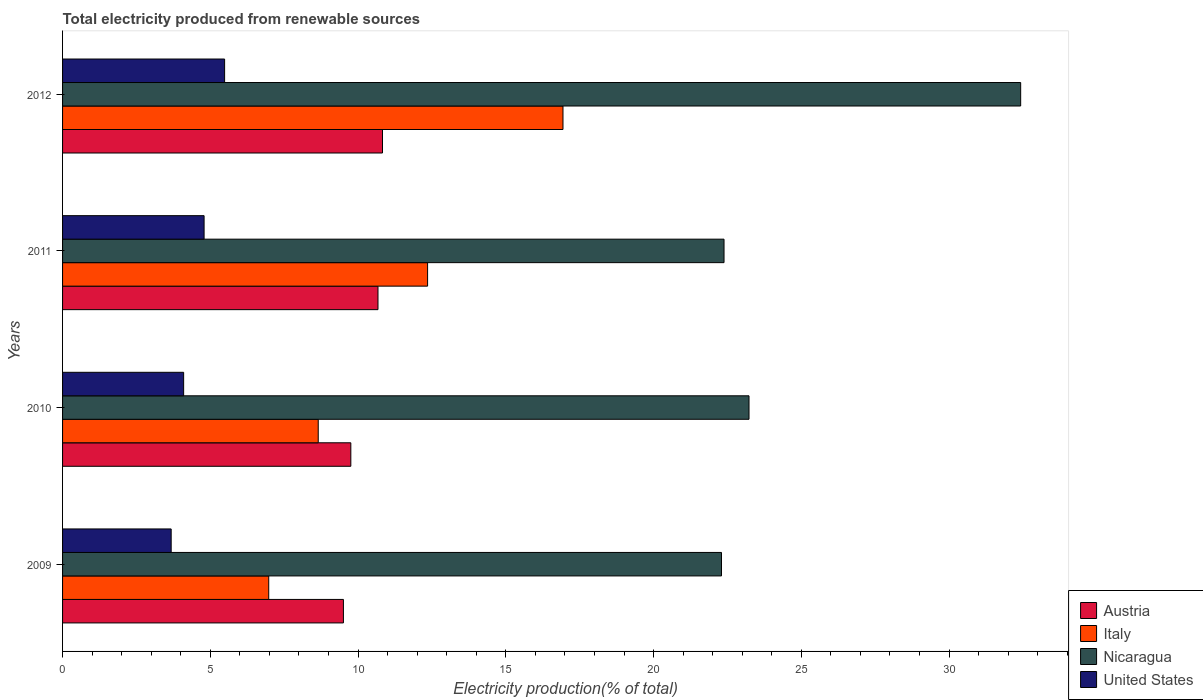How many groups of bars are there?
Your answer should be compact. 4. Are the number of bars on each tick of the Y-axis equal?
Your answer should be compact. Yes. How many bars are there on the 2nd tick from the top?
Ensure brevity in your answer.  4. What is the label of the 3rd group of bars from the top?
Ensure brevity in your answer.  2010. In how many cases, is the number of bars for a given year not equal to the number of legend labels?
Your answer should be compact. 0. What is the total electricity produced in Austria in 2012?
Make the answer very short. 10.83. Across all years, what is the maximum total electricity produced in United States?
Offer a very short reply. 5.48. Across all years, what is the minimum total electricity produced in United States?
Offer a terse response. 3.68. In which year was the total electricity produced in Italy maximum?
Give a very brief answer. 2012. In which year was the total electricity produced in Nicaragua minimum?
Provide a short and direct response. 2009. What is the total total electricity produced in Austria in the graph?
Keep it short and to the point. 40.76. What is the difference between the total electricity produced in Austria in 2010 and that in 2011?
Give a very brief answer. -0.92. What is the difference between the total electricity produced in United States in 2010 and the total electricity produced in Nicaragua in 2009?
Offer a terse response. -18.2. What is the average total electricity produced in Austria per year?
Offer a very short reply. 10.19. In the year 2010, what is the difference between the total electricity produced in Nicaragua and total electricity produced in Austria?
Ensure brevity in your answer.  13.48. In how many years, is the total electricity produced in United States greater than 30 %?
Provide a succinct answer. 0. What is the ratio of the total electricity produced in Austria in 2009 to that in 2010?
Ensure brevity in your answer.  0.97. What is the difference between the highest and the second highest total electricity produced in United States?
Your response must be concise. 0.69. What is the difference between the highest and the lowest total electricity produced in Italy?
Give a very brief answer. 9.96. Is the sum of the total electricity produced in Italy in 2010 and 2011 greater than the maximum total electricity produced in Austria across all years?
Ensure brevity in your answer.  Yes. What does the 2nd bar from the top in 2011 represents?
Your answer should be compact. Nicaragua. What does the 1st bar from the bottom in 2010 represents?
Your response must be concise. Austria. How many bars are there?
Offer a terse response. 16. How many years are there in the graph?
Your answer should be very brief. 4. Does the graph contain grids?
Your answer should be very brief. No. Where does the legend appear in the graph?
Ensure brevity in your answer.  Bottom right. How many legend labels are there?
Provide a succinct answer. 4. How are the legend labels stacked?
Provide a short and direct response. Vertical. What is the title of the graph?
Make the answer very short. Total electricity produced from renewable sources. Does "Norway" appear as one of the legend labels in the graph?
Your response must be concise. No. What is the Electricity production(% of total) in Austria in 2009?
Your response must be concise. 9.5. What is the Electricity production(% of total) in Italy in 2009?
Ensure brevity in your answer.  6.98. What is the Electricity production(% of total) of Nicaragua in 2009?
Your answer should be very brief. 22.3. What is the Electricity production(% of total) of United States in 2009?
Your answer should be very brief. 3.68. What is the Electricity production(% of total) of Austria in 2010?
Provide a short and direct response. 9.76. What is the Electricity production(% of total) of Italy in 2010?
Keep it short and to the point. 8.65. What is the Electricity production(% of total) of Nicaragua in 2010?
Your answer should be very brief. 23.23. What is the Electricity production(% of total) in United States in 2010?
Provide a short and direct response. 4.1. What is the Electricity production(% of total) in Austria in 2011?
Your response must be concise. 10.67. What is the Electricity production(% of total) in Italy in 2011?
Ensure brevity in your answer.  12.35. What is the Electricity production(% of total) in Nicaragua in 2011?
Your answer should be very brief. 22.38. What is the Electricity production(% of total) in United States in 2011?
Give a very brief answer. 4.79. What is the Electricity production(% of total) of Austria in 2012?
Make the answer very short. 10.83. What is the Electricity production(% of total) in Italy in 2012?
Your answer should be compact. 16.94. What is the Electricity production(% of total) of Nicaragua in 2012?
Offer a terse response. 32.42. What is the Electricity production(% of total) in United States in 2012?
Your response must be concise. 5.48. Across all years, what is the maximum Electricity production(% of total) in Austria?
Offer a terse response. 10.83. Across all years, what is the maximum Electricity production(% of total) of Italy?
Keep it short and to the point. 16.94. Across all years, what is the maximum Electricity production(% of total) of Nicaragua?
Offer a very short reply. 32.42. Across all years, what is the maximum Electricity production(% of total) in United States?
Provide a short and direct response. 5.48. Across all years, what is the minimum Electricity production(% of total) of Austria?
Your answer should be very brief. 9.5. Across all years, what is the minimum Electricity production(% of total) in Italy?
Provide a succinct answer. 6.98. Across all years, what is the minimum Electricity production(% of total) of Nicaragua?
Offer a very short reply. 22.3. Across all years, what is the minimum Electricity production(% of total) in United States?
Provide a succinct answer. 3.68. What is the total Electricity production(% of total) of Austria in the graph?
Your answer should be compact. 40.76. What is the total Electricity production(% of total) of Italy in the graph?
Your response must be concise. 44.92. What is the total Electricity production(% of total) of Nicaragua in the graph?
Provide a succinct answer. 100.34. What is the total Electricity production(% of total) in United States in the graph?
Ensure brevity in your answer.  18.05. What is the difference between the Electricity production(% of total) of Austria in 2009 and that in 2010?
Your response must be concise. -0.25. What is the difference between the Electricity production(% of total) in Italy in 2009 and that in 2010?
Your response must be concise. -1.67. What is the difference between the Electricity production(% of total) in Nicaragua in 2009 and that in 2010?
Offer a very short reply. -0.93. What is the difference between the Electricity production(% of total) in United States in 2009 and that in 2010?
Your answer should be very brief. -0.42. What is the difference between the Electricity production(% of total) of Austria in 2009 and that in 2011?
Your response must be concise. -1.17. What is the difference between the Electricity production(% of total) in Italy in 2009 and that in 2011?
Give a very brief answer. -5.38. What is the difference between the Electricity production(% of total) of Nicaragua in 2009 and that in 2011?
Your answer should be very brief. -0.09. What is the difference between the Electricity production(% of total) of United States in 2009 and that in 2011?
Offer a very short reply. -1.11. What is the difference between the Electricity production(% of total) in Austria in 2009 and that in 2012?
Give a very brief answer. -1.32. What is the difference between the Electricity production(% of total) of Italy in 2009 and that in 2012?
Give a very brief answer. -9.96. What is the difference between the Electricity production(% of total) of Nicaragua in 2009 and that in 2012?
Provide a succinct answer. -10.12. What is the difference between the Electricity production(% of total) of United States in 2009 and that in 2012?
Provide a succinct answer. -1.81. What is the difference between the Electricity production(% of total) of Austria in 2010 and that in 2011?
Your answer should be very brief. -0.92. What is the difference between the Electricity production(% of total) of Italy in 2010 and that in 2011?
Give a very brief answer. -3.7. What is the difference between the Electricity production(% of total) in Nicaragua in 2010 and that in 2011?
Your answer should be very brief. 0.85. What is the difference between the Electricity production(% of total) of United States in 2010 and that in 2011?
Keep it short and to the point. -0.69. What is the difference between the Electricity production(% of total) in Austria in 2010 and that in 2012?
Ensure brevity in your answer.  -1.07. What is the difference between the Electricity production(% of total) in Italy in 2010 and that in 2012?
Provide a succinct answer. -8.28. What is the difference between the Electricity production(% of total) in Nicaragua in 2010 and that in 2012?
Make the answer very short. -9.19. What is the difference between the Electricity production(% of total) in United States in 2010 and that in 2012?
Ensure brevity in your answer.  -1.39. What is the difference between the Electricity production(% of total) of Austria in 2011 and that in 2012?
Offer a very short reply. -0.15. What is the difference between the Electricity production(% of total) of Italy in 2011 and that in 2012?
Provide a succinct answer. -4.58. What is the difference between the Electricity production(% of total) in Nicaragua in 2011 and that in 2012?
Provide a succinct answer. -10.04. What is the difference between the Electricity production(% of total) in United States in 2011 and that in 2012?
Offer a terse response. -0.69. What is the difference between the Electricity production(% of total) of Austria in 2009 and the Electricity production(% of total) of Italy in 2010?
Make the answer very short. 0.85. What is the difference between the Electricity production(% of total) in Austria in 2009 and the Electricity production(% of total) in Nicaragua in 2010?
Your answer should be very brief. -13.73. What is the difference between the Electricity production(% of total) in Austria in 2009 and the Electricity production(% of total) in United States in 2010?
Your response must be concise. 5.41. What is the difference between the Electricity production(% of total) of Italy in 2009 and the Electricity production(% of total) of Nicaragua in 2010?
Your answer should be compact. -16.25. What is the difference between the Electricity production(% of total) of Italy in 2009 and the Electricity production(% of total) of United States in 2010?
Your answer should be compact. 2.88. What is the difference between the Electricity production(% of total) of Nicaragua in 2009 and the Electricity production(% of total) of United States in 2010?
Offer a terse response. 18.2. What is the difference between the Electricity production(% of total) in Austria in 2009 and the Electricity production(% of total) in Italy in 2011?
Your answer should be very brief. -2.85. What is the difference between the Electricity production(% of total) of Austria in 2009 and the Electricity production(% of total) of Nicaragua in 2011?
Provide a short and direct response. -12.88. What is the difference between the Electricity production(% of total) in Austria in 2009 and the Electricity production(% of total) in United States in 2011?
Your answer should be very brief. 4.72. What is the difference between the Electricity production(% of total) of Italy in 2009 and the Electricity production(% of total) of Nicaragua in 2011?
Make the answer very short. -15.41. What is the difference between the Electricity production(% of total) of Italy in 2009 and the Electricity production(% of total) of United States in 2011?
Your answer should be very brief. 2.19. What is the difference between the Electricity production(% of total) of Nicaragua in 2009 and the Electricity production(% of total) of United States in 2011?
Provide a short and direct response. 17.51. What is the difference between the Electricity production(% of total) of Austria in 2009 and the Electricity production(% of total) of Italy in 2012?
Provide a succinct answer. -7.43. What is the difference between the Electricity production(% of total) of Austria in 2009 and the Electricity production(% of total) of Nicaragua in 2012?
Offer a very short reply. -22.92. What is the difference between the Electricity production(% of total) of Austria in 2009 and the Electricity production(% of total) of United States in 2012?
Your answer should be compact. 4.02. What is the difference between the Electricity production(% of total) in Italy in 2009 and the Electricity production(% of total) in Nicaragua in 2012?
Ensure brevity in your answer.  -25.45. What is the difference between the Electricity production(% of total) in Italy in 2009 and the Electricity production(% of total) in United States in 2012?
Offer a terse response. 1.49. What is the difference between the Electricity production(% of total) of Nicaragua in 2009 and the Electricity production(% of total) of United States in 2012?
Provide a short and direct response. 16.82. What is the difference between the Electricity production(% of total) of Austria in 2010 and the Electricity production(% of total) of Italy in 2011?
Give a very brief answer. -2.6. What is the difference between the Electricity production(% of total) in Austria in 2010 and the Electricity production(% of total) in Nicaragua in 2011?
Give a very brief answer. -12.63. What is the difference between the Electricity production(% of total) in Austria in 2010 and the Electricity production(% of total) in United States in 2011?
Provide a succinct answer. 4.97. What is the difference between the Electricity production(% of total) of Italy in 2010 and the Electricity production(% of total) of Nicaragua in 2011?
Give a very brief answer. -13.73. What is the difference between the Electricity production(% of total) of Italy in 2010 and the Electricity production(% of total) of United States in 2011?
Ensure brevity in your answer.  3.86. What is the difference between the Electricity production(% of total) in Nicaragua in 2010 and the Electricity production(% of total) in United States in 2011?
Give a very brief answer. 18.44. What is the difference between the Electricity production(% of total) in Austria in 2010 and the Electricity production(% of total) in Italy in 2012?
Your answer should be very brief. -7.18. What is the difference between the Electricity production(% of total) in Austria in 2010 and the Electricity production(% of total) in Nicaragua in 2012?
Offer a very short reply. -22.67. What is the difference between the Electricity production(% of total) of Austria in 2010 and the Electricity production(% of total) of United States in 2012?
Provide a short and direct response. 4.27. What is the difference between the Electricity production(% of total) in Italy in 2010 and the Electricity production(% of total) in Nicaragua in 2012?
Provide a short and direct response. -23.77. What is the difference between the Electricity production(% of total) of Italy in 2010 and the Electricity production(% of total) of United States in 2012?
Offer a very short reply. 3.17. What is the difference between the Electricity production(% of total) of Nicaragua in 2010 and the Electricity production(% of total) of United States in 2012?
Make the answer very short. 17.75. What is the difference between the Electricity production(% of total) of Austria in 2011 and the Electricity production(% of total) of Italy in 2012?
Your response must be concise. -6.26. What is the difference between the Electricity production(% of total) of Austria in 2011 and the Electricity production(% of total) of Nicaragua in 2012?
Keep it short and to the point. -21.75. What is the difference between the Electricity production(% of total) in Austria in 2011 and the Electricity production(% of total) in United States in 2012?
Make the answer very short. 5.19. What is the difference between the Electricity production(% of total) of Italy in 2011 and the Electricity production(% of total) of Nicaragua in 2012?
Your response must be concise. -20.07. What is the difference between the Electricity production(% of total) in Italy in 2011 and the Electricity production(% of total) in United States in 2012?
Give a very brief answer. 6.87. What is the difference between the Electricity production(% of total) in Nicaragua in 2011 and the Electricity production(% of total) in United States in 2012?
Offer a very short reply. 16.9. What is the average Electricity production(% of total) of Austria per year?
Offer a terse response. 10.19. What is the average Electricity production(% of total) in Italy per year?
Provide a short and direct response. 11.23. What is the average Electricity production(% of total) of Nicaragua per year?
Offer a terse response. 25.08. What is the average Electricity production(% of total) in United States per year?
Offer a very short reply. 4.51. In the year 2009, what is the difference between the Electricity production(% of total) of Austria and Electricity production(% of total) of Italy?
Offer a terse response. 2.53. In the year 2009, what is the difference between the Electricity production(% of total) in Austria and Electricity production(% of total) in Nicaragua?
Offer a very short reply. -12.79. In the year 2009, what is the difference between the Electricity production(% of total) in Austria and Electricity production(% of total) in United States?
Make the answer very short. 5.83. In the year 2009, what is the difference between the Electricity production(% of total) in Italy and Electricity production(% of total) in Nicaragua?
Provide a succinct answer. -15.32. In the year 2009, what is the difference between the Electricity production(% of total) of Italy and Electricity production(% of total) of United States?
Give a very brief answer. 3.3. In the year 2009, what is the difference between the Electricity production(% of total) in Nicaragua and Electricity production(% of total) in United States?
Your answer should be compact. 18.62. In the year 2010, what is the difference between the Electricity production(% of total) of Austria and Electricity production(% of total) of Italy?
Provide a short and direct response. 1.1. In the year 2010, what is the difference between the Electricity production(% of total) of Austria and Electricity production(% of total) of Nicaragua?
Offer a very short reply. -13.48. In the year 2010, what is the difference between the Electricity production(% of total) in Austria and Electricity production(% of total) in United States?
Offer a terse response. 5.66. In the year 2010, what is the difference between the Electricity production(% of total) in Italy and Electricity production(% of total) in Nicaragua?
Offer a terse response. -14.58. In the year 2010, what is the difference between the Electricity production(% of total) in Italy and Electricity production(% of total) in United States?
Make the answer very short. 4.55. In the year 2010, what is the difference between the Electricity production(% of total) of Nicaragua and Electricity production(% of total) of United States?
Provide a succinct answer. 19.13. In the year 2011, what is the difference between the Electricity production(% of total) in Austria and Electricity production(% of total) in Italy?
Provide a succinct answer. -1.68. In the year 2011, what is the difference between the Electricity production(% of total) in Austria and Electricity production(% of total) in Nicaragua?
Your response must be concise. -11.71. In the year 2011, what is the difference between the Electricity production(% of total) of Austria and Electricity production(% of total) of United States?
Offer a very short reply. 5.88. In the year 2011, what is the difference between the Electricity production(% of total) in Italy and Electricity production(% of total) in Nicaragua?
Make the answer very short. -10.03. In the year 2011, what is the difference between the Electricity production(% of total) of Italy and Electricity production(% of total) of United States?
Your answer should be very brief. 7.56. In the year 2011, what is the difference between the Electricity production(% of total) in Nicaragua and Electricity production(% of total) in United States?
Make the answer very short. 17.6. In the year 2012, what is the difference between the Electricity production(% of total) of Austria and Electricity production(% of total) of Italy?
Keep it short and to the point. -6.11. In the year 2012, what is the difference between the Electricity production(% of total) in Austria and Electricity production(% of total) in Nicaragua?
Offer a terse response. -21.6. In the year 2012, what is the difference between the Electricity production(% of total) of Austria and Electricity production(% of total) of United States?
Your answer should be compact. 5.34. In the year 2012, what is the difference between the Electricity production(% of total) of Italy and Electricity production(% of total) of Nicaragua?
Offer a very short reply. -15.49. In the year 2012, what is the difference between the Electricity production(% of total) in Italy and Electricity production(% of total) in United States?
Provide a succinct answer. 11.45. In the year 2012, what is the difference between the Electricity production(% of total) in Nicaragua and Electricity production(% of total) in United States?
Provide a succinct answer. 26.94. What is the ratio of the Electricity production(% of total) of Austria in 2009 to that in 2010?
Provide a succinct answer. 0.97. What is the ratio of the Electricity production(% of total) of Italy in 2009 to that in 2010?
Give a very brief answer. 0.81. What is the ratio of the Electricity production(% of total) in Nicaragua in 2009 to that in 2010?
Your answer should be compact. 0.96. What is the ratio of the Electricity production(% of total) of United States in 2009 to that in 2010?
Your answer should be very brief. 0.9. What is the ratio of the Electricity production(% of total) in Austria in 2009 to that in 2011?
Your response must be concise. 0.89. What is the ratio of the Electricity production(% of total) in Italy in 2009 to that in 2011?
Provide a short and direct response. 0.56. What is the ratio of the Electricity production(% of total) of Nicaragua in 2009 to that in 2011?
Keep it short and to the point. 1. What is the ratio of the Electricity production(% of total) in United States in 2009 to that in 2011?
Make the answer very short. 0.77. What is the ratio of the Electricity production(% of total) in Austria in 2009 to that in 2012?
Your answer should be very brief. 0.88. What is the ratio of the Electricity production(% of total) of Italy in 2009 to that in 2012?
Provide a short and direct response. 0.41. What is the ratio of the Electricity production(% of total) in Nicaragua in 2009 to that in 2012?
Make the answer very short. 0.69. What is the ratio of the Electricity production(% of total) of United States in 2009 to that in 2012?
Your answer should be very brief. 0.67. What is the ratio of the Electricity production(% of total) in Austria in 2010 to that in 2011?
Your answer should be compact. 0.91. What is the ratio of the Electricity production(% of total) of Italy in 2010 to that in 2011?
Give a very brief answer. 0.7. What is the ratio of the Electricity production(% of total) of Nicaragua in 2010 to that in 2011?
Provide a short and direct response. 1.04. What is the ratio of the Electricity production(% of total) in United States in 2010 to that in 2011?
Ensure brevity in your answer.  0.86. What is the ratio of the Electricity production(% of total) of Austria in 2010 to that in 2012?
Your response must be concise. 0.9. What is the ratio of the Electricity production(% of total) of Italy in 2010 to that in 2012?
Provide a succinct answer. 0.51. What is the ratio of the Electricity production(% of total) in Nicaragua in 2010 to that in 2012?
Keep it short and to the point. 0.72. What is the ratio of the Electricity production(% of total) of United States in 2010 to that in 2012?
Provide a succinct answer. 0.75. What is the ratio of the Electricity production(% of total) in Austria in 2011 to that in 2012?
Ensure brevity in your answer.  0.99. What is the ratio of the Electricity production(% of total) in Italy in 2011 to that in 2012?
Provide a short and direct response. 0.73. What is the ratio of the Electricity production(% of total) of Nicaragua in 2011 to that in 2012?
Provide a short and direct response. 0.69. What is the ratio of the Electricity production(% of total) of United States in 2011 to that in 2012?
Provide a succinct answer. 0.87. What is the difference between the highest and the second highest Electricity production(% of total) in Austria?
Offer a terse response. 0.15. What is the difference between the highest and the second highest Electricity production(% of total) in Italy?
Give a very brief answer. 4.58. What is the difference between the highest and the second highest Electricity production(% of total) in Nicaragua?
Your answer should be compact. 9.19. What is the difference between the highest and the second highest Electricity production(% of total) in United States?
Provide a short and direct response. 0.69. What is the difference between the highest and the lowest Electricity production(% of total) of Austria?
Your response must be concise. 1.32. What is the difference between the highest and the lowest Electricity production(% of total) of Italy?
Make the answer very short. 9.96. What is the difference between the highest and the lowest Electricity production(% of total) in Nicaragua?
Keep it short and to the point. 10.12. What is the difference between the highest and the lowest Electricity production(% of total) in United States?
Your response must be concise. 1.81. 